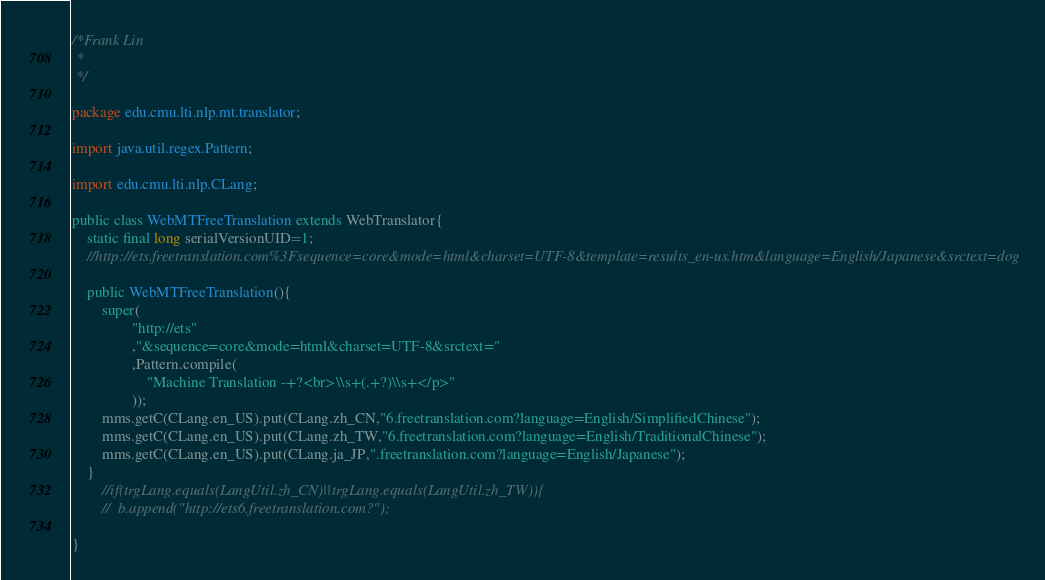<code> <loc_0><loc_0><loc_500><loc_500><_Java_>/*Frank Lin
 *
 */

package edu.cmu.lti.nlp.mt.translator;

import java.util.regex.Pattern;

import edu.cmu.lti.nlp.CLang;

public class WebMTFreeTranslation extends WebTranslator{
	static final long serialVersionUID=1;
	//http://ets.freetranslation.com%3Fsequence=core&mode=html&charset=UTF-8&template=results_en-us.htm&language=English/Japanese&srctext=dog

	public WebMTFreeTranslation(){
		super(
				"http://ets"
				,"&sequence=core&mode=html&charset=UTF-8&srctext="
				,Pattern.compile(
					"Machine Translation -+?<br>\\s+(.+?)\\s+</p>"
				));	
		mms.getC(CLang.en_US).put(CLang.zh_CN,"6.freetranslation.com?language=English/SimplifiedChinese");
		mms.getC(CLang.en_US).put(CLang.zh_TW,"6.freetranslation.com?language=English/TraditionalChinese");
		mms.getC(CLang.en_US).put(CLang.ja_JP,".freetranslation.com?language=English/Japanese");
	}	
		//if(trgLang.equals(LangUtil.zh_CN)||trgLang.equals(LangUtil.zh_TW)){
		//	b.append("http://ets6.freetranslation.com?");

}
</code> 